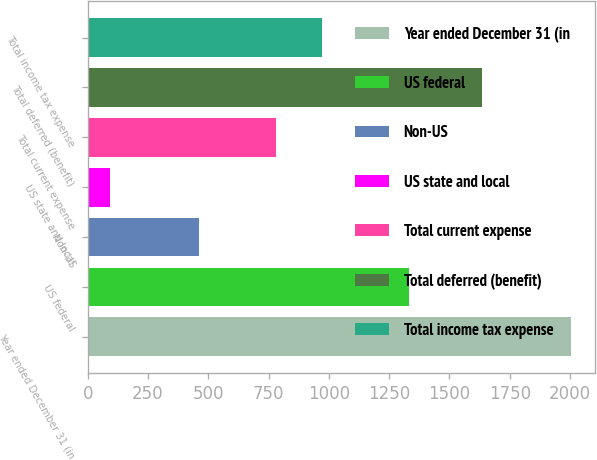Convert chart. <chart><loc_0><loc_0><loc_500><loc_500><bar_chart><fcel>Year ended December 31 (in<fcel>US federal<fcel>Non-US<fcel>US state and local<fcel>Total current expense<fcel>Total deferred (benefit)<fcel>Total income tax expense<nl><fcel>2002<fcel>1334<fcel>461<fcel>93<fcel>780<fcel>1636<fcel>970.9<nl></chart> 